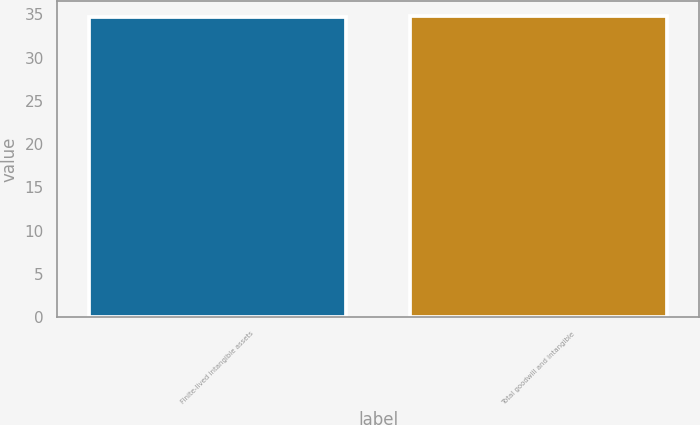Convert chart. <chart><loc_0><loc_0><loc_500><loc_500><bar_chart><fcel>Finite-lived intangible assets<fcel>Total goodwill and intangible<nl><fcel>34.7<fcel>34.8<nl></chart> 